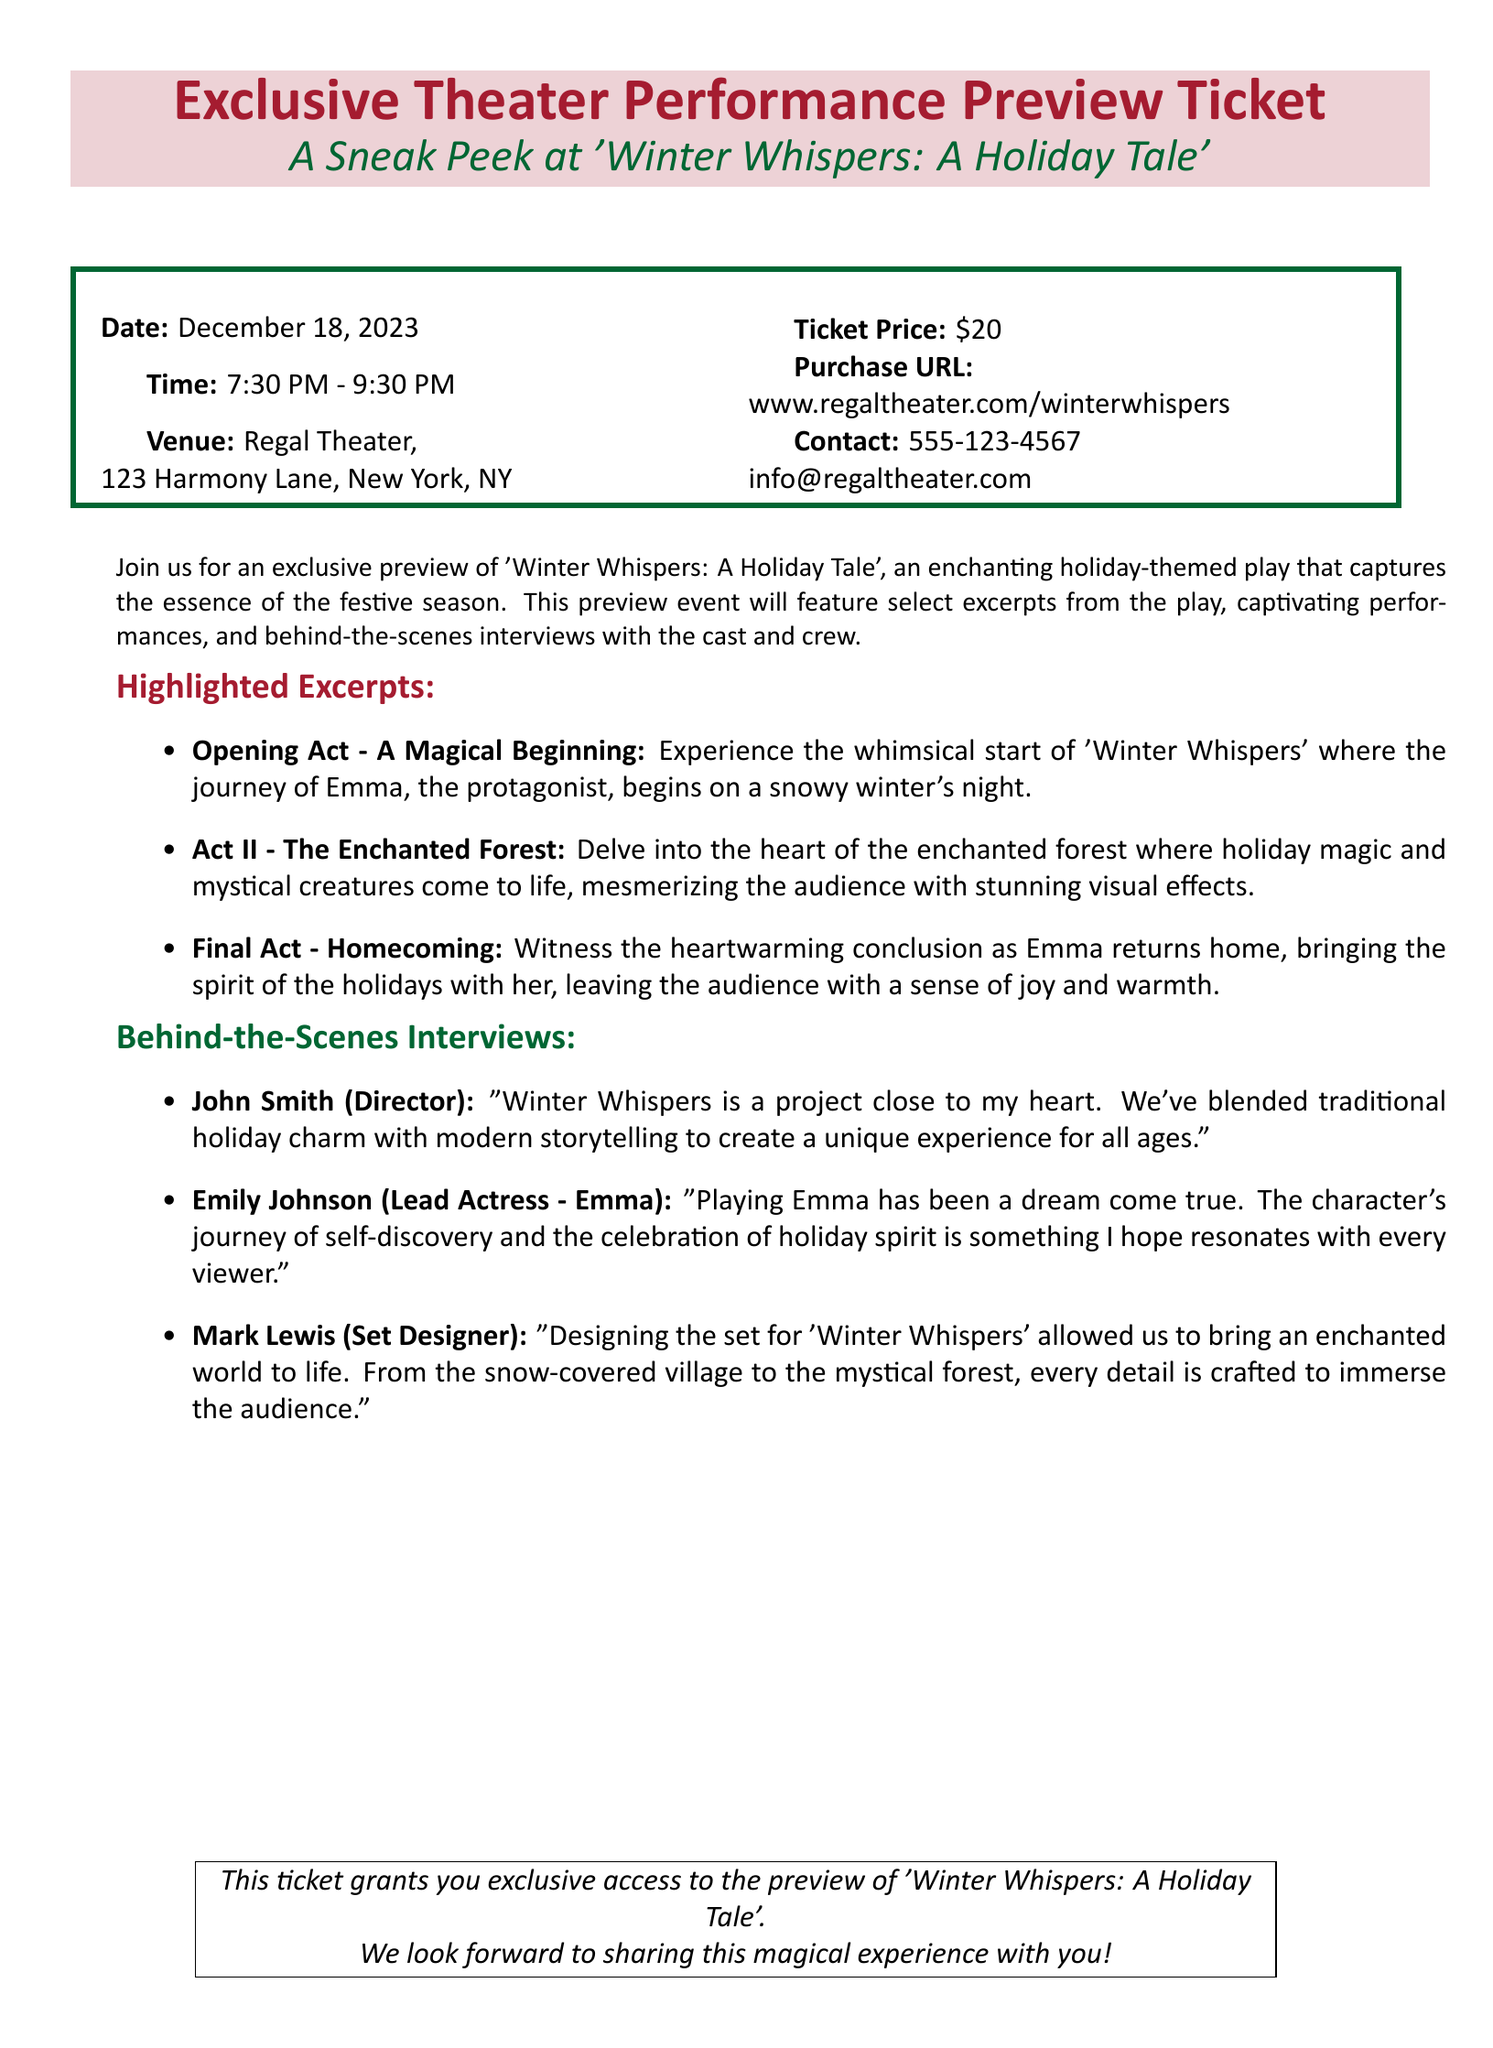What is the title of the play? The title of the play is mentioned in the document as 'Winter Whispers: A Holiday Tale'.
Answer: 'Winter Whispers: A Holiday Tale' When is the performance preview scheduled? The date of the performance preview is specified in the document as December 18, 2023.
Answer: December 18, 2023 Where is the venue located? The venue is described in the document with its address, which is Regal Theater, 123 Harmony Lane, New York, NY.
Answer: Regal Theater, 123 Harmony Lane, New York, NY What is the ticket price? The ticket price is clearly stated in the document as $20.
Answer: $20 Who is the lead actress? The name of the lead actress is mentioned in the behind-the-scenes interviews section as Emily Johnson.
Answer: Emily Johnson What is the main theme of the play according to the director? The director, John Smith, describes the theme focusing on blending traditional holiday charm with modern storytelling.
Answer: Traditional holiday charm with modern storytelling How long is the preview event? The duration of the event is specified as 2 hours, from 7:30 PM to 9:30 PM.
Answer: 2 hours What features are included in the preview event? The document mentions features like select excerpts from the play and behind-the-scenes interviews with the cast and crew.
Answer: Select excerpts and behind-the-scenes interviews Which character's journey is primarily focused on in the play? The protagonist mentioned in the document is Emma, who embarks on a journey in the play.
Answer: Emma 